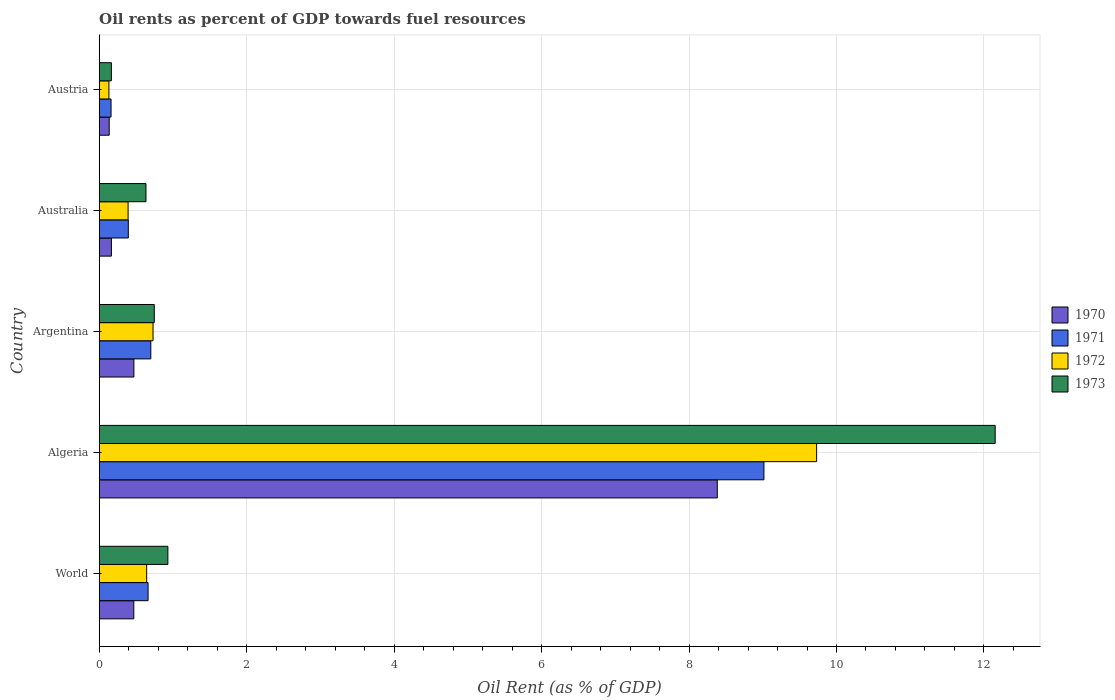How many bars are there on the 3rd tick from the top?
Offer a very short reply. 4. What is the label of the 5th group of bars from the top?
Your answer should be very brief. World. In how many cases, is the number of bars for a given country not equal to the number of legend labels?
Provide a short and direct response. 0. What is the oil rent in 1973 in Algeria?
Offer a terse response. 12.15. Across all countries, what is the maximum oil rent in 1973?
Your response must be concise. 12.15. Across all countries, what is the minimum oil rent in 1971?
Provide a succinct answer. 0.16. In which country was the oil rent in 1971 maximum?
Your answer should be compact. Algeria. What is the total oil rent in 1971 in the graph?
Offer a very short reply. 10.93. What is the difference between the oil rent in 1973 in Algeria and that in Australia?
Provide a succinct answer. 11.52. What is the difference between the oil rent in 1970 in Australia and the oil rent in 1972 in World?
Your response must be concise. -0.48. What is the average oil rent in 1973 per country?
Your answer should be compact. 2.93. What is the difference between the oil rent in 1973 and oil rent in 1970 in Austria?
Your response must be concise. 0.03. What is the ratio of the oil rent in 1973 in Argentina to that in Australia?
Ensure brevity in your answer.  1.18. What is the difference between the highest and the second highest oil rent in 1972?
Provide a short and direct response. 9. What is the difference between the highest and the lowest oil rent in 1973?
Your answer should be very brief. 11.99. Is the sum of the oil rent in 1971 in Argentina and Australia greater than the maximum oil rent in 1970 across all countries?
Your answer should be very brief. No. What does the 2nd bar from the top in Algeria represents?
Offer a terse response. 1972. What does the 2nd bar from the bottom in Australia represents?
Make the answer very short. 1971. What is the difference between two consecutive major ticks on the X-axis?
Your answer should be very brief. 2. Does the graph contain grids?
Your response must be concise. Yes. Where does the legend appear in the graph?
Make the answer very short. Center right. How many legend labels are there?
Offer a very short reply. 4. How are the legend labels stacked?
Offer a terse response. Vertical. What is the title of the graph?
Provide a short and direct response. Oil rents as percent of GDP towards fuel resources. Does "1996" appear as one of the legend labels in the graph?
Your response must be concise. No. What is the label or title of the X-axis?
Your answer should be compact. Oil Rent (as % of GDP). What is the Oil Rent (as % of GDP) of 1970 in World?
Ensure brevity in your answer.  0.47. What is the Oil Rent (as % of GDP) of 1971 in World?
Your response must be concise. 0.66. What is the Oil Rent (as % of GDP) of 1972 in World?
Your answer should be compact. 0.64. What is the Oil Rent (as % of GDP) in 1973 in World?
Keep it short and to the point. 0.93. What is the Oil Rent (as % of GDP) of 1970 in Algeria?
Ensure brevity in your answer.  8.38. What is the Oil Rent (as % of GDP) in 1971 in Algeria?
Provide a succinct answer. 9.02. What is the Oil Rent (as % of GDP) in 1972 in Algeria?
Your response must be concise. 9.73. What is the Oil Rent (as % of GDP) of 1973 in Algeria?
Provide a short and direct response. 12.15. What is the Oil Rent (as % of GDP) in 1970 in Argentina?
Give a very brief answer. 0.47. What is the Oil Rent (as % of GDP) in 1971 in Argentina?
Provide a short and direct response. 0.7. What is the Oil Rent (as % of GDP) in 1972 in Argentina?
Offer a very short reply. 0.73. What is the Oil Rent (as % of GDP) of 1973 in Argentina?
Your answer should be very brief. 0.75. What is the Oil Rent (as % of GDP) in 1970 in Australia?
Your response must be concise. 0.17. What is the Oil Rent (as % of GDP) of 1971 in Australia?
Keep it short and to the point. 0.39. What is the Oil Rent (as % of GDP) in 1972 in Australia?
Make the answer very short. 0.39. What is the Oil Rent (as % of GDP) of 1973 in Australia?
Provide a short and direct response. 0.63. What is the Oil Rent (as % of GDP) of 1970 in Austria?
Offer a terse response. 0.14. What is the Oil Rent (as % of GDP) of 1971 in Austria?
Your answer should be compact. 0.16. What is the Oil Rent (as % of GDP) of 1972 in Austria?
Your response must be concise. 0.13. What is the Oil Rent (as % of GDP) in 1973 in Austria?
Your response must be concise. 0.16. Across all countries, what is the maximum Oil Rent (as % of GDP) of 1970?
Your answer should be very brief. 8.38. Across all countries, what is the maximum Oil Rent (as % of GDP) in 1971?
Offer a terse response. 9.02. Across all countries, what is the maximum Oil Rent (as % of GDP) of 1972?
Your answer should be compact. 9.73. Across all countries, what is the maximum Oil Rent (as % of GDP) of 1973?
Make the answer very short. 12.15. Across all countries, what is the minimum Oil Rent (as % of GDP) of 1970?
Your answer should be very brief. 0.14. Across all countries, what is the minimum Oil Rent (as % of GDP) in 1971?
Keep it short and to the point. 0.16. Across all countries, what is the minimum Oil Rent (as % of GDP) in 1972?
Offer a very short reply. 0.13. Across all countries, what is the minimum Oil Rent (as % of GDP) in 1973?
Ensure brevity in your answer.  0.16. What is the total Oil Rent (as % of GDP) in 1970 in the graph?
Offer a very short reply. 9.62. What is the total Oil Rent (as % of GDP) in 1971 in the graph?
Provide a short and direct response. 10.93. What is the total Oil Rent (as % of GDP) of 1972 in the graph?
Keep it short and to the point. 11.63. What is the total Oil Rent (as % of GDP) of 1973 in the graph?
Offer a terse response. 14.63. What is the difference between the Oil Rent (as % of GDP) of 1970 in World and that in Algeria?
Your answer should be very brief. -7.91. What is the difference between the Oil Rent (as % of GDP) of 1971 in World and that in Algeria?
Give a very brief answer. -8.35. What is the difference between the Oil Rent (as % of GDP) in 1972 in World and that in Algeria?
Your answer should be very brief. -9.09. What is the difference between the Oil Rent (as % of GDP) in 1973 in World and that in Algeria?
Offer a terse response. -11.22. What is the difference between the Oil Rent (as % of GDP) in 1970 in World and that in Argentina?
Provide a succinct answer. -0. What is the difference between the Oil Rent (as % of GDP) of 1971 in World and that in Argentina?
Your response must be concise. -0.04. What is the difference between the Oil Rent (as % of GDP) in 1972 in World and that in Argentina?
Your answer should be compact. -0.09. What is the difference between the Oil Rent (as % of GDP) of 1973 in World and that in Argentina?
Make the answer very short. 0.18. What is the difference between the Oil Rent (as % of GDP) in 1970 in World and that in Australia?
Give a very brief answer. 0.3. What is the difference between the Oil Rent (as % of GDP) in 1971 in World and that in Australia?
Your answer should be very brief. 0.27. What is the difference between the Oil Rent (as % of GDP) of 1972 in World and that in Australia?
Provide a succinct answer. 0.25. What is the difference between the Oil Rent (as % of GDP) of 1973 in World and that in Australia?
Offer a terse response. 0.3. What is the difference between the Oil Rent (as % of GDP) in 1970 in World and that in Austria?
Your answer should be compact. 0.33. What is the difference between the Oil Rent (as % of GDP) of 1971 in World and that in Austria?
Give a very brief answer. 0.5. What is the difference between the Oil Rent (as % of GDP) of 1972 in World and that in Austria?
Provide a short and direct response. 0.51. What is the difference between the Oil Rent (as % of GDP) in 1973 in World and that in Austria?
Your response must be concise. 0.77. What is the difference between the Oil Rent (as % of GDP) of 1970 in Algeria and that in Argentina?
Offer a very short reply. 7.91. What is the difference between the Oil Rent (as % of GDP) in 1971 in Algeria and that in Argentina?
Your answer should be compact. 8.32. What is the difference between the Oil Rent (as % of GDP) in 1972 in Algeria and that in Argentina?
Provide a succinct answer. 9. What is the difference between the Oil Rent (as % of GDP) in 1973 in Algeria and that in Argentina?
Give a very brief answer. 11.41. What is the difference between the Oil Rent (as % of GDP) of 1970 in Algeria and that in Australia?
Your response must be concise. 8.22. What is the difference between the Oil Rent (as % of GDP) of 1971 in Algeria and that in Australia?
Ensure brevity in your answer.  8.62. What is the difference between the Oil Rent (as % of GDP) in 1972 in Algeria and that in Australia?
Your answer should be very brief. 9.34. What is the difference between the Oil Rent (as % of GDP) of 1973 in Algeria and that in Australia?
Offer a terse response. 11.52. What is the difference between the Oil Rent (as % of GDP) of 1970 in Algeria and that in Austria?
Provide a short and direct response. 8.25. What is the difference between the Oil Rent (as % of GDP) in 1971 in Algeria and that in Austria?
Ensure brevity in your answer.  8.86. What is the difference between the Oil Rent (as % of GDP) of 1972 in Algeria and that in Austria?
Your answer should be very brief. 9.6. What is the difference between the Oil Rent (as % of GDP) in 1973 in Algeria and that in Austria?
Offer a very short reply. 11.99. What is the difference between the Oil Rent (as % of GDP) in 1970 in Argentina and that in Australia?
Provide a short and direct response. 0.3. What is the difference between the Oil Rent (as % of GDP) of 1971 in Argentina and that in Australia?
Keep it short and to the point. 0.31. What is the difference between the Oil Rent (as % of GDP) in 1972 in Argentina and that in Australia?
Offer a very short reply. 0.34. What is the difference between the Oil Rent (as % of GDP) in 1973 in Argentina and that in Australia?
Your response must be concise. 0.11. What is the difference between the Oil Rent (as % of GDP) of 1970 in Argentina and that in Austria?
Offer a very short reply. 0.33. What is the difference between the Oil Rent (as % of GDP) in 1971 in Argentina and that in Austria?
Give a very brief answer. 0.54. What is the difference between the Oil Rent (as % of GDP) in 1972 in Argentina and that in Austria?
Make the answer very short. 0.6. What is the difference between the Oil Rent (as % of GDP) of 1973 in Argentina and that in Austria?
Ensure brevity in your answer.  0.58. What is the difference between the Oil Rent (as % of GDP) of 1970 in Australia and that in Austria?
Keep it short and to the point. 0.03. What is the difference between the Oil Rent (as % of GDP) of 1971 in Australia and that in Austria?
Offer a very short reply. 0.23. What is the difference between the Oil Rent (as % of GDP) in 1972 in Australia and that in Austria?
Give a very brief answer. 0.26. What is the difference between the Oil Rent (as % of GDP) in 1973 in Australia and that in Austria?
Your answer should be compact. 0.47. What is the difference between the Oil Rent (as % of GDP) of 1970 in World and the Oil Rent (as % of GDP) of 1971 in Algeria?
Offer a terse response. -8.55. What is the difference between the Oil Rent (as % of GDP) in 1970 in World and the Oil Rent (as % of GDP) in 1972 in Algeria?
Your answer should be very brief. -9.26. What is the difference between the Oil Rent (as % of GDP) in 1970 in World and the Oil Rent (as % of GDP) in 1973 in Algeria?
Provide a succinct answer. -11.68. What is the difference between the Oil Rent (as % of GDP) in 1971 in World and the Oil Rent (as % of GDP) in 1972 in Algeria?
Ensure brevity in your answer.  -9.07. What is the difference between the Oil Rent (as % of GDP) in 1971 in World and the Oil Rent (as % of GDP) in 1973 in Algeria?
Your answer should be compact. -11.49. What is the difference between the Oil Rent (as % of GDP) of 1972 in World and the Oil Rent (as % of GDP) of 1973 in Algeria?
Keep it short and to the point. -11.51. What is the difference between the Oil Rent (as % of GDP) of 1970 in World and the Oil Rent (as % of GDP) of 1971 in Argentina?
Give a very brief answer. -0.23. What is the difference between the Oil Rent (as % of GDP) in 1970 in World and the Oil Rent (as % of GDP) in 1972 in Argentina?
Your answer should be very brief. -0.26. What is the difference between the Oil Rent (as % of GDP) of 1970 in World and the Oil Rent (as % of GDP) of 1973 in Argentina?
Provide a short and direct response. -0.28. What is the difference between the Oil Rent (as % of GDP) of 1971 in World and the Oil Rent (as % of GDP) of 1972 in Argentina?
Make the answer very short. -0.07. What is the difference between the Oil Rent (as % of GDP) of 1971 in World and the Oil Rent (as % of GDP) of 1973 in Argentina?
Offer a terse response. -0.08. What is the difference between the Oil Rent (as % of GDP) in 1972 in World and the Oil Rent (as % of GDP) in 1973 in Argentina?
Make the answer very short. -0.1. What is the difference between the Oil Rent (as % of GDP) of 1970 in World and the Oil Rent (as % of GDP) of 1971 in Australia?
Keep it short and to the point. 0.07. What is the difference between the Oil Rent (as % of GDP) in 1970 in World and the Oil Rent (as % of GDP) in 1972 in Australia?
Keep it short and to the point. 0.08. What is the difference between the Oil Rent (as % of GDP) in 1970 in World and the Oil Rent (as % of GDP) in 1973 in Australia?
Ensure brevity in your answer.  -0.17. What is the difference between the Oil Rent (as % of GDP) of 1971 in World and the Oil Rent (as % of GDP) of 1972 in Australia?
Your response must be concise. 0.27. What is the difference between the Oil Rent (as % of GDP) in 1971 in World and the Oil Rent (as % of GDP) in 1973 in Australia?
Offer a very short reply. 0.03. What is the difference between the Oil Rent (as % of GDP) in 1972 in World and the Oil Rent (as % of GDP) in 1973 in Australia?
Give a very brief answer. 0.01. What is the difference between the Oil Rent (as % of GDP) in 1970 in World and the Oil Rent (as % of GDP) in 1971 in Austria?
Offer a very short reply. 0.31. What is the difference between the Oil Rent (as % of GDP) in 1970 in World and the Oil Rent (as % of GDP) in 1972 in Austria?
Your response must be concise. 0.34. What is the difference between the Oil Rent (as % of GDP) in 1970 in World and the Oil Rent (as % of GDP) in 1973 in Austria?
Your answer should be very brief. 0.3. What is the difference between the Oil Rent (as % of GDP) in 1971 in World and the Oil Rent (as % of GDP) in 1972 in Austria?
Give a very brief answer. 0.53. What is the difference between the Oil Rent (as % of GDP) of 1971 in World and the Oil Rent (as % of GDP) of 1973 in Austria?
Provide a short and direct response. 0.5. What is the difference between the Oil Rent (as % of GDP) in 1972 in World and the Oil Rent (as % of GDP) in 1973 in Austria?
Your response must be concise. 0.48. What is the difference between the Oil Rent (as % of GDP) of 1970 in Algeria and the Oil Rent (as % of GDP) of 1971 in Argentina?
Offer a very short reply. 7.68. What is the difference between the Oil Rent (as % of GDP) of 1970 in Algeria and the Oil Rent (as % of GDP) of 1972 in Argentina?
Provide a short and direct response. 7.65. What is the difference between the Oil Rent (as % of GDP) of 1970 in Algeria and the Oil Rent (as % of GDP) of 1973 in Argentina?
Offer a terse response. 7.64. What is the difference between the Oil Rent (as % of GDP) of 1971 in Algeria and the Oil Rent (as % of GDP) of 1972 in Argentina?
Make the answer very short. 8.29. What is the difference between the Oil Rent (as % of GDP) of 1971 in Algeria and the Oil Rent (as % of GDP) of 1973 in Argentina?
Give a very brief answer. 8.27. What is the difference between the Oil Rent (as % of GDP) of 1972 in Algeria and the Oil Rent (as % of GDP) of 1973 in Argentina?
Keep it short and to the point. 8.98. What is the difference between the Oil Rent (as % of GDP) of 1970 in Algeria and the Oil Rent (as % of GDP) of 1971 in Australia?
Offer a terse response. 7.99. What is the difference between the Oil Rent (as % of GDP) in 1970 in Algeria and the Oil Rent (as % of GDP) in 1972 in Australia?
Offer a very short reply. 7.99. What is the difference between the Oil Rent (as % of GDP) of 1970 in Algeria and the Oil Rent (as % of GDP) of 1973 in Australia?
Give a very brief answer. 7.75. What is the difference between the Oil Rent (as % of GDP) of 1971 in Algeria and the Oil Rent (as % of GDP) of 1972 in Australia?
Offer a very short reply. 8.62. What is the difference between the Oil Rent (as % of GDP) of 1971 in Algeria and the Oil Rent (as % of GDP) of 1973 in Australia?
Give a very brief answer. 8.38. What is the difference between the Oil Rent (as % of GDP) in 1972 in Algeria and the Oil Rent (as % of GDP) in 1973 in Australia?
Offer a terse response. 9.1. What is the difference between the Oil Rent (as % of GDP) of 1970 in Algeria and the Oil Rent (as % of GDP) of 1971 in Austria?
Provide a short and direct response. 8.22. What is the difference between the Oil Rent (as % of GDP) of 1970 in Algeria and the Oil Rent (as % of GDP) of 1972 in Austria?
Make the answer very short. 8.25. What is the difference between the Oil Rent (as % of GDP) in 1970 in Algeria and the Oil Rent (as % of GDP) in 1973 in Austria?
Your response must be concise. 8.22. What is the difference between the Oil Rent (as % of GDP) in 1971 in Algeria and the Oil Rent (as % of GDP) in 1972 in Austria?
Your answer should be very brief. 8.88. What is the difference between the Oil Rent (as % of GDP) in 1971 in Algeria and the Oil Rent (as % of GDP) in 1973 in Austria?
Your answer should be very brief. 8.85. What is the difference between the Oil Rent (as % of GDP) in 1972 in Algeria and the Oil Rent (as % of GDP) in 1973 in Austria?
Offer a very short reply. 9.57. What is the difference between the Oil Rent (as % of GDP) of 1970 in Argentina and the Oil Rent (as % of GDP) of 1971 in Australia?
Ensure brevity in your answer.  0.08. What is the difference between the Oil Rent (as % of GDP) in 1970 in Argentina and the Oil Rent (as % of GDP) in 1972 in Australia?
Ensure brevity in your answer.  0.08. What is the difference between the Oil Rent (as % of GDP) of 1970 in Argentina and the Oil Rent (as % of GDP) of 1973 in Australia?
Ensure brevity in your answer.  -0.16. What is the difference between the Oil Rent (as % of GDP) in 1971 in Argentina and the Oil Rent (as % of GDP) in 1972 in Australia?
Your response must be concise. 0.31. What is the difference between the Oil Rent (as % of GDP) in 1971 in Argentina and the Oil Rent (as % of GDP) in 1973 in Australia?
Your answer should be very brief. 0.07. What is the difference between the Oil Rent (as % of GDP) of 1972 in Argentina and the Oil Rent (as % of GDP) of 1973 in Australia?
Provide a short and direct response. 0.1. What is the difference between the Oil Rent (as % of GDP) of 1970 in Argentina and the Oil Rent (as % of GDP) of 1971 in Austria?
Ensure brevity in your answer.  0.31. What is the difference between the Oil Rent (as % of GDP) of 1970 in Argentina and the Oil Rent (as % of GDP) of 1972 in Austria?
Your answer should be very brief. 0.34. What is the difference between the Oil Rent (as % of GDP) of 1970 in Argentina and the Oil Rent (as % of GDP) of 1973 in Austria?
Your answer should be very brief. 0.31. What is the difference between the Oil Rent (as % of GDP) in 1971 in Argentina and the Oil Rent (as % of GDP) in 1972 in Austria?
Give a very brief answer. 0.57. What is the difference between the Oil Rent (as % of GDP) of 1971 in Argentina and the Oil Rent (as % of GDP) of 1973 in Austria?
Give a very brief answer. 0.54. What is the difference between the Oil Rent (as % of GDP) of 1972 in Argentina and the Oil Rent (as % of GDP) of 1973 in Austria?
Your answer should be very brief. 0.57. What is the difference between the Oil Rent (as % of GDP) of 1970 in Australia and the Oil Rent (as % of GDP) of 1971 in Austria?
Your answer should be very brief. 0. What is the difference between the Oil Rent (as % of GDP) of 1970 in Australia and the Oil Rent (as % of GDP) of 1972 in Austria?
Give a very brief answer. 0.03. What is the difference between the Oil Rent (as % of GDP) in 1970 in Australia and the Oil Rent (as % of GDP) in 1973 in Austria?
Keep it short and to the point. 0. What is the difference between the Oil Rent (as % of GDP) of 1971 in Australia and the Oil Rent (as % of GDP) of 1972 in Austria?
Your answer should be compact. 0.26. What is the difference between the Oil Rent (as % of GDP) in 1971 in Australia and the Oil Rent (as % of GDP) in 1973 in Austria?
Ensure brevity in your answer.  0.23. What is the difference between the Oil Rent (as % of GDP) of 1972 in Australia and the Oil Rent (as % of GDP) of 1973 in Austria?
Keep it short and to the point. 0.23. What is the average Oil Rent (as % of GDP) in 1970 per country?
Ensure brevity in your answer.  1.92. What is the average Oil Rent (as % of GDP) in 1971 per country?
Your response must be concise. 2.19. What is the average Oil Rent (as % of GDP) in 1972 per country?
Your answer should be very brief. 2.33. What is the average Oil Rent (as % of GDP) in 1973 per country?
Your answer should be very brief. 2.93. What is the difference between the Oil Rent (as % of GDP) in 1970 and Oil Rent (as % of GDP) in 1971 in World?
Make the answer very short. -0.19. What is the difference between the Oil Rent (as % of GDP) in 1970 and Oil Rent (as % of GDP) in 1972 in World?
Give a very brief answer. -0.17. What is the difference between the Oil Rent (as % of GDP) in 1970 and Oil Rent (as % of GDP) in 1973 in World?
Your response must be concise. -0.46. What is the difference between the Oil Rent (as % of GDP) in 1971 and Oil Rent (as % of GDP) in 1972 in World?
Keep it short and to the point. 0.02. What is the difference between the Oil Rent (as % of GDP) in 1971 and Oil Rent (as % of GDP) in 1973 in World?
Provide a short and direct response. -0.27. What is the difference between the Oil Rent (as % of GDP) in 1972 and Oil Rent (as % of GDP) in 1973 in World?
Offer a very short reply. -0.29. What is the difference between the Oil Rent (as % of GDP) in 1970 and Oil Rent (as % of GDP) in 1971 in Algeria?
Provide a short and direct response. -0.63. What is the difference between the Oil Rent (as % of GDP) in 1970 and Oil Rent (as % of GDP) in 1972 in Algeria?
Your answer should be compact. -1.35. What is the difference between the Oil Rent (as % of GDP) in 1970 and Oil Rent (as % of GDP) in 1973 in Algeria?
Offer a terse response. -3.77. What is the difference between the Oil Rent (as % of GDP) of 1971 and Oil Rent (as % of GDP) of 1972 in Algeria?
Provide a short and direct response. -0.71. What is the difference between the Oil Rent (as % of GDP) in 1971 and Oil Rent (as % of GDP) in 1973 in Algeria?
Give a very brief answer. -3.14. What is the difference between the Oil Rent (as % of GDP) in 1972 and Oil Rent (as % of GDP) in 1973 in Algeria?
Offer a terse response. -2.42. What is the difference between the Oil Rent (as % of GDP) of 1970 and Oil Rent (as % of GDP) of 1971 in Argentina?
Offer a terse response. -0.23. What is the difference between the Oil Rent (as % of GDP) of 1970 and Oil Rent (as % of GDP) of 1972 in Argentina?
Provide a succinct answer. -0.26. What is the difference between the Oil Rent (as % of GDP) of 1970 and Oil Rent (as % of GDP) of 1973 in Argentina?
Keep it short and to the point. -0.28. What is the difference between the Oil Rent (as % of GDP) of 1971 and Oil Rent (as % of GDP) of 1972 in Argentina?
Provide a succinct answer. -0.03. What is the difference between the Oil Rent (as % of GDP) of 1971 and Oil Rent (as % of GDP) of 1973 in Argentina?
Keep it short and to the point. -0.05. What is the difference between the Oil Rent (as % of GDP) of 1972 and Oil Rent (as % of GDP) of 1973 in Argentina?
Offer a very short reply. -0.02. What is the difference between the Oil Rent (as % of GDP) in 1970 and Oil Rent (as % of GDP) in 1971 in Australia?
Give a very brief answer. -0.23. What is the difference between the Oil Rent (as % of GDP) of 1970 and Oil Rent (as % of GDP) of 1972 in Australia?
Provide a short and direct response. -0.23. What is the difference between the Oil Rent (as % of GDP) in 1970 and Oil Rent (as % of GDP) in 1973 in Australia?
Offer a very short reply. -0.47. What is the difference between the Oil Rent (as % of GDP) of 1971 and Oil Rent (as % of GDP) of 1972 in Australia?
Provide a short and direct response. 0. What is the difference between the Oil Rent (as % of GDP) of 1971 and Oil Rent (as % of GDP) of 1973 in Australia?
Offer a terse response. -0.24. What is the difference between the Oil Rent (as % of GDP) in 1972 and Oil Rent (as % of GDP) in 1973 in Australia?
Your answer should be compact. -0.24. What is the difference between the Oil Rent (as % of GDP) of 1970 and Oil Rent (as % of GDP) of 1971 in Austria?
Keep it short and to the point. -0.03. What is the difference between the Oil Rent (as % of GDP) in 1970 and Oil Rent (as % of GDP) in 1972 in Austria?
Make the answer very short. 0. What is the difference between the Oil Rent (as % of GDP) in 1970 and Oil Rent (as % of GDP) in 1973 in Austria?
Provide a short and direct response. -0.03. What is the difference between the Oil Rent (as % of GDP) in 1971 and Oil Rent (as % of GDP) in 1972 in Austria?
Give a very brief answer. 0.03. What is the difference between the Oil Rent (as % of GDP) in 1971 and Oil Rent (as % of GDP) in 1973 in Austria?
Offer a very short reply. -0. What is the difference between the Oil Rent (as % of GDP) of 1972 and Oil Rent (as % of GDP) of 1973 in Austria?
Provide a short and direct response. -0.03. What is the ratio of the Oil Rent (as % of GDP) of 1970 in World to that in Algeria?
Provide a succinct answer. 0.06. What is the ratio of the Oil Rent (as % of GDP) in 1971 in World to that in Algeria?
Ensure brevity in your answer.  0.07. What is the ratio of the Oil Rent (as % of GDP) in 1972 in World to that in Algeria?
Provide a succinct answer. 0.07. What is the ratio of the Oil Rent (as % of GDP) of 1973 in World to that in Algeria?
Give a very brief answer. 0.08. What is the ratio of the Oil Rent (as % of GDP) of 1971 in World to that in Argentina?
Ensure brevity in your answer.  0.95. What is the ratio of the Oil Rent (as % of GDP) of 1972 in World to that in Argentina?
Your answer should be compact. 0.88. What is the ratio of the Oil Rent (as % of GDP) of 1973 in World to that in Argentina?
Give a very brief answer. 1.25. What is the ratio of the Oil Rent (as % of GDP) of 1970 in World to that in Australia?
Keep it short and to the point. 2.84. What is the ratio of the Oil Rent (as % of GDP) of 1971 in World to that in Australia?
Ensure brevity in your answer.  1.68. What is the ratio of the Oil Rent (as % of GDP) in 1972 in World to that in Australia?
Provide a short and direct response. 1.64. What is the ratio of the Oil Rent (as % of GDP) of 1973 in World to that in Australia?
Your answer should be very brief. 1.47. What is the ratio of the Oil Rent (as % of GDP) of 1970 in World to that in Austria?
Provide a succinct answer. 3.47. What is the ratio of the Oil Rent (as % of GDP) of 1971 in World to that in Austria?
Ensure brevity in your answer.  4.13. What is the ratio of the Oil Rent (as % of GDP) of 1972 in World to that in Austria?
Ensure brevity in your answer.  4.89. What is the ratio of the Oil Rent (as % of GDP) in 1973 in World to that in Austria?
Offer a terse response. 5.65. What is the ratio of the Oil Rent (as % of GDP) in 1970 in Algeria to that in Argentina?
Offer a terse response. 17.83. What is the ratio of the Oil Rent (as % of GDP) in 1971 in Algeria to that in Argentina?
Offer a terse response. 12.88. What is the ratio of the Oil Rent (as % of GDP) in 1972 in Algeria to that in Argentina?
Ensure brevity in your answer.  13.33. What is the ratio of the Oil Rent (as % of GDP) of 1973 in Algeria to that in Argentina?
Your response must be concise. 16.27. What is the ratio of the Oil Rent (as % of GDP) in 1970 in Algeria to that in Australia?
Keep it short and to the point. 50.73. What is the ratio of the Oil Rent (as % of GDP) in 1971 in Algeria to that in Australia?
Give a very brief answer. 22.84. What is the ratio of the Oil Rent (as % of GDP) of 1972 in Algeria to that in Australia?
Offer a terse response. 24.84. What is the ratio of the Oil Rent (as % of GDP) in 1973 in Algeria to that in Australia?
Your answer should be compact. 19.16. What is the ratio of the Oil Rent (as % of GDP) in 1970 in Algeria to that in Austria?
Make the answer very short. 61.94. What is the ratio of the Oil Rent (as % of GDP) in 1971 in Algeria to that in Austria?
Offer a terse response. 56.22. What is the ratio of the Oil Rent (as % of GDP) of 1972 in Algeria to that in Austria?
Provide a short and direct response. 73.89. What is the ratio of the Oil Rent (as % of GDP) in 1973 in Algeria to that in Austria?
Provide a succinct answer. 73.69. What is the ratio of the Oil Rent (as % of GDP) of 1970 in Argentina to that in Australia?
Offer a very short reply. 2.85. What is the ratio of the Oil Rent (as % of GDP) of 1971 in Argentina to that in Australia?
Give a very brief answer. 1.77. What is the ratio of the Oil Rent (as % of GDP) in 1972 in Argentina to that in Australia?
Keep it short and to the point. 1.86. What is the ratio of the Oil Rent (as % of GDP) in 1973 in Argentina to that in Australia?
Provide a short and direct response. 1.18. What is the ratio of the Oil Rent (as % of GDP) of 1970 in Argentina to that in Austria?
Offer a terse response. 3.47. What is the ratio of the Oil Rent (as % of GDP) in 1971 in Argentina to that in Austria?
Provide a succinct answer. 4.36. What is the ratio of the Oil Rent (as % of GDP) of 1972 in Argentina to that in Austria?
Your response must be concise. 5.54. What is the ratio of the Oil Rent (as % of GDP) of 1973 in Argentina to that in Austria?
Offer a terse response. 4.53. What is the ratio of the Oil Rent (as % of GDP) in 1970 in Australia to that in Austria?
Offer a terse response. 1.22. What is the ratio of the Oil Rent (as % of GDP) of 1971 in Australia to that in Austria?
Offer a terse response. 2.46. What is the ratio of the Oil Rent (as % of GDP) in 1972 in Australia to that in Austria?
Your response must be concise. 2.97. What is the ratio of the Oil Rent (as % of GDP) of 1973 in Australia to that in Austria?
Your answer should be very brief. 3.85. What is the difference between the highest and the second highest Oil Rent (as % of GDP) in 1970?
Your response must be concise. 7.91. What is the difference between the highest and the second highest Oil Rent (as % of GDP) of 1971?
Give a very brief answer. 8.32. What is the difference between the highest and the second highest Oil Rent (as % of GDP) in 1972?
Your response must be concise. 9. What is the difference between the highest and the second highest Oil Rent (as % of GDP) in 1973?
Ensure brevity in your answer.  11.22. What is the difference between the highest and the lowest Oil Rent (as % of GDP) in 1970?
Provide a succinct answer. 8.25. What is the difference between the highest and the lowest Oil Rent (as % of GDP) in 1971?
Your answer should be very brief. 8.86. What is the difference between the highest and the lowest Oil Rent (as % of GDP) of 1972?
Your answer should be compact. 9.6. What is the difference between the highest and the lowest Oil Rent (as % of GDP) of 1973?
Provide a succinct answer. 11.99. 